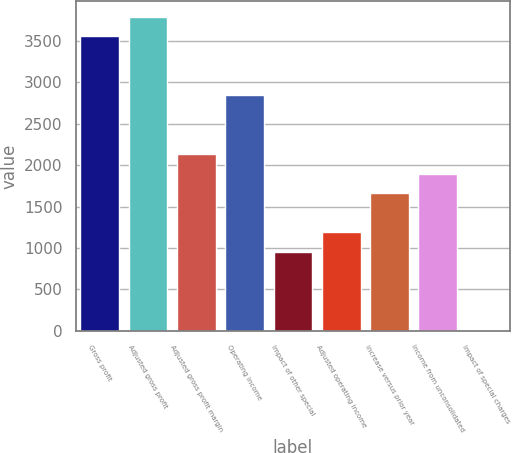<chart> <loc_0><loc_0><loc_500><loc_500><bar_chart><fcel>Gross profit<fcel>Adjusted gross profit<fcel>Adjusted gross profit margin<fcel>Operating income<fcel>Impact of other special<fcel>Adjusted operating income<fcel>increase versus prior year<fcel>Income from unconsolidated<fcel>Impact of special charges<nl><fcel>3555.5<fcel>3792.28<fcel>2134.82<fcel>2845.16<fcel>950.92<fcel>1187.7<fcel>1661.26<fcel>1898.04<fcel>3.8<nl></chart> 